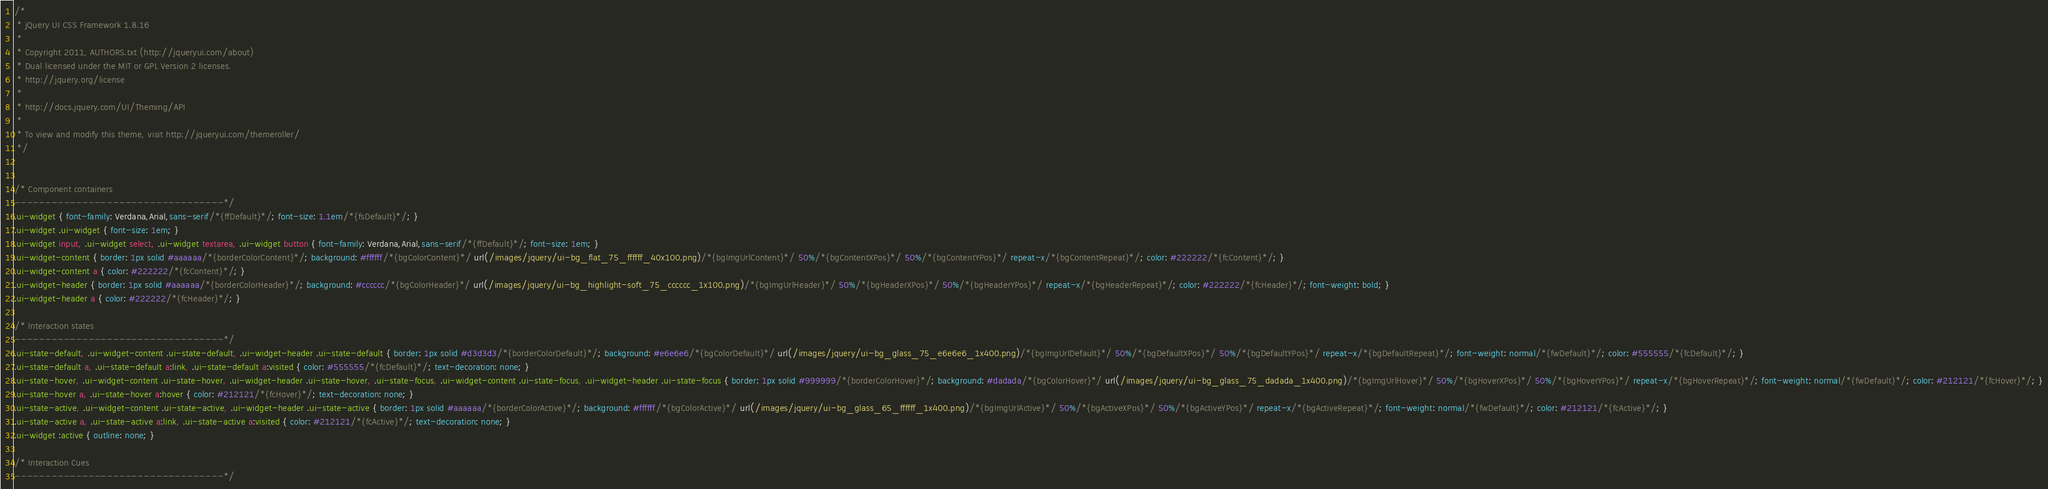Convert code to text. <code><loc_0><loc_0><loc_500><loc_500><_CSS_>/*
 * jQuery UI CSS Framework 1.8.16
 *
 * Copyright 2011, AUTHORS.txt (http://jqueryui.com/about)
 * Dual licensed under the MIT or GPL Version 2 licenses.
 * http://jquery.org/license
 *
 * http://docs.jquery.com/UI/Theming/API
 *
 * To view and modify this theme, visit http://jqueryui.com/themeroller/
 */


/* Component containers
----------------------------------*/
.ui-widget { font-family: Verdana,Arial,sans-serif/*{ffDefault}*/; font-size: 1.1em/*{fsDefault}*/; }
.ui-widget .ui-widget { font-size: 1em; }
.ui-widget input, .ui-widget select, .ui-widget textarea, .ui-widget button { font-family: Verdana,Arial,sans-serif/*{ffDefault}*/; font-size: 1em; }
.ui-widget-content { border: 1px solid #aaaaaa/*{borderColorContent}*/; background: #ffffff/*{bgColorContent}*/ url(/images/jquery/ui-bg_flat_75_ffffff_40x100.png)/*{bgImgUrlContent}*/ 50%/*{bgContentXPos}*/ 50%/*{bgContentYPos}*/ repeat-x/*{bgContentRepeat}*/; color: #222222/*{fcContent}*/; }
.ui-widget-content a { color: #222222/*{fcContent}*/; }
.ui-widget-header { border: 1px solid #aaaaaa/*{borderColorHeader}*/; background: #cccccc/*{bgColorHeader}*/ url(/images/jquery/ui-bg_highlight-soft_75_cccccc_1x100.png)/*{bgImgUrlHeader}*/ 50%/*{bgHeaderXPos}*/ 50%/*{bgHeaderYPos}*/ repeat-x/*{bgHeaderRepeat}*/; color: #222222/*{fcHeader}*/; font-weight: bold; }
.ui-widget-header a { color: #222222/*{fcHeader}*/; }

/* Interaction states
----------------------------------*/
.ui-state-default, .ui-widget-content .ui-state-default, .ui-widget-header .ui-state-default { border: 1px solid #d3d3d3/*{borderColorDefault}*/; background: #e6e6e6/*{bgColorDefault}*/ url(/images/jquery/ui-bg_glass_75_e6e6e6_1x400.png)/*{bgImgUrlDefault}*/ 50%/*{bgDefaultXPos}*/ 50%/*{bgDefaultYPos}*/ repeat-x/*{bgDefaultRepeat}*/; font-weight: normal/*{fwDefault}*/; color: #555555/*{fcDefault}*/; }
.ui-state-default a, .ui-state-default a:link, .ui-state-default a:visited { color: #555555/*{fcDefault}*/; text-decoration: none; }
.ui-state-hover, .ui-widget-content .ui-state-hover, .ui-widget-header .ui-state-hover, .ui-state-focus, .ui-widget-content .ui-state-focus, .ui-widget-header .ui-state-focus { border: 1px solid #999999/*{borderColorHover}*/; background: #dadada/*{bgColorHover}*/ url(/images/jquery/ui-bg_glass_75_dadada_1x400.png)/*{bgImgUrlHover}*/ 50%/*{bgHoverXPos}*/ 50%/*{bgHoverYPos}*/ repeat-x/*{bgHoverRepeat}*/; font-weight: normal/*{fwDefault}*/; color: #212121/*{fcHover}*/; }
.ui-state-hover a, .ui-state-hover a:hover { color: #212121/*{fcHover}*/; text-decoration: none; }
.ui-state-active, .ui-widget-content .ui-state-active, .ui-widget-header .ui-state-active { border: 1px solid #aaaaaa/*{borderColorActive}*/; background: #ffffff/*{bgColorActive}*/ url(/images/jquery/ui-bg_glass_65_ffffff_1x400.png)/*{bgImgUrlActive}*/ 50%/*{bgActiveXPos}*/ 50%/*{bgActiveYPos}*/ repeat-x/*{bgActiveRepeat}*/; font-weight: normal/*{fwDefault}*/; color: #212121/*{fcActive}*/; }
.ui-state-active a, .ui-state-active a:link, .ui-state-active a:visited { color: #212121/*{fcActive}*/; text-decoration: none; }
.ui-widget :active { outline: none; }

/* Interaction Cues
----------------------------------*/</code> 